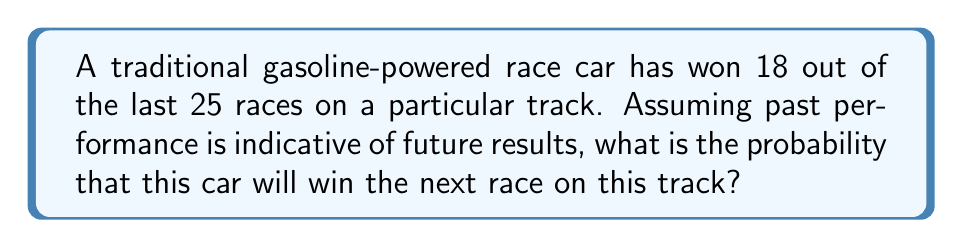Provide a solution to this math problem. To solve this problem, we'll use the classical definition of probability:

$$ P(A) = \frac{\text{Number of favorable outcomes}}{\text{Total number of possible outcomes}} $$

In this case:
1. Number of favorable outcomes (wins): 18
2. Total number of possible outcomes (races): 25

Let's substitute these values into our probability formula:

$$ P(\text{win}) = \frac{18}{25} $$

To simplify this fraction:
1. Find the greatest common divisor (GCD) of 18 and 25
   $GCD(18, 25) = 1$
2. Divide both numerator and denominator by the GCD
   $\frac{18 \div 1}{25 \div 1} = \frac{18}{25}$

The fraction cannot be simplified further.

To express this as a decimal, divide 18 by 25:
$$ \frac{18}{25} = 0.72 $$

Therefore, the probability of the race car winning the next race is 0.72 or 72%.
Answer: $\frac{18}{25}$ or 0.72 or 72% 